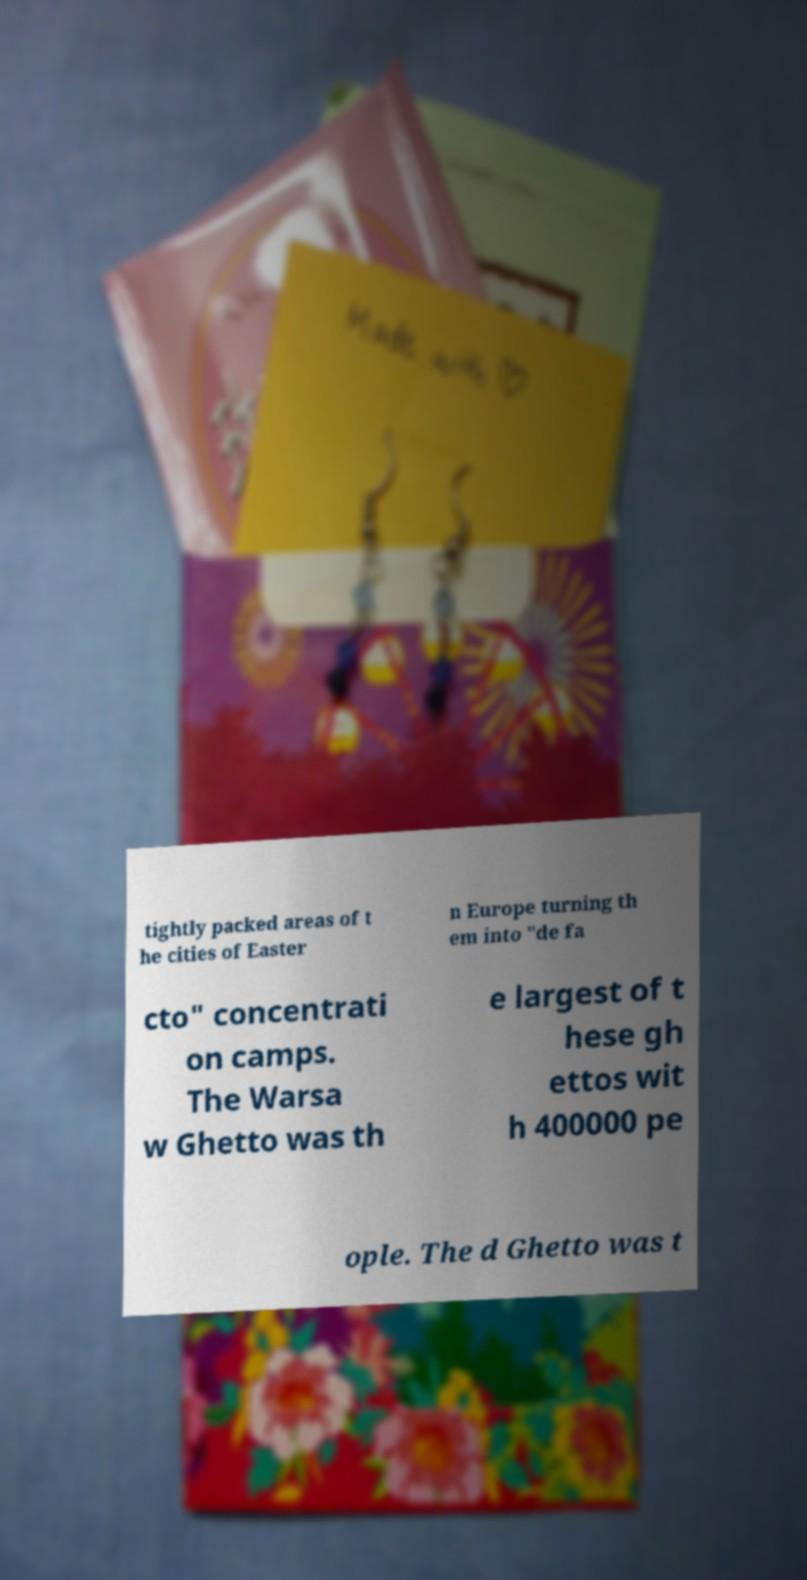Could you extract and type out the text from this image? tightly packed areas of t he cities of Easter n Europe turning th em into "de fa cto" concentrati on camps. The Warsa w Ghetto was th e largest of t hese gh ettos wit h 400000 pe ople. The d Ghetto was t 